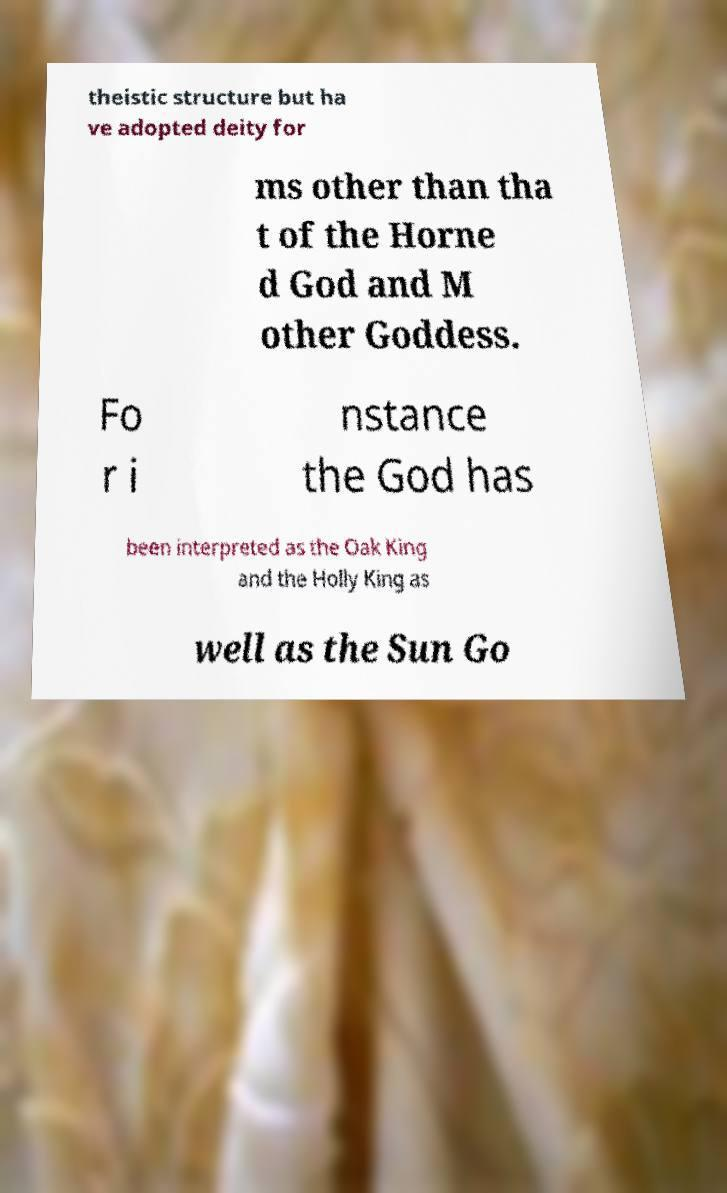Can you accurately transcribe the text from the provided image for me? theistic structure but ha ve adopted deity for ms other than tha t of the Horne d God and M other Goddess. Fo r i nstance the God has been interpreted as the Oak King and the Holly King as well as the Sun Go 